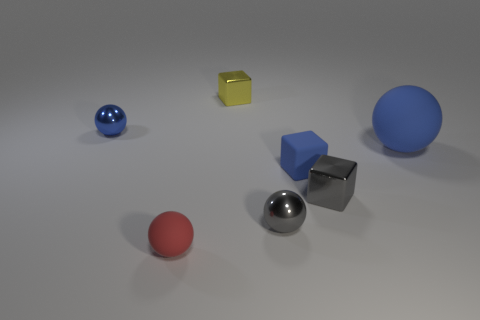Can you tell me more about the materials of these objects and how they might feel to the touch? Based on the visual clues, the blue and red spheres seem to have a matte finish, indicating a texture that might feel smooth and slightly rubbery to the touch. The large blue sphere appears to have a glossier surface, potentially resembling polished plastic. The metallic sphere and cube likely have a cool, hard, and smooth metal surface typical of polished metal objects. 